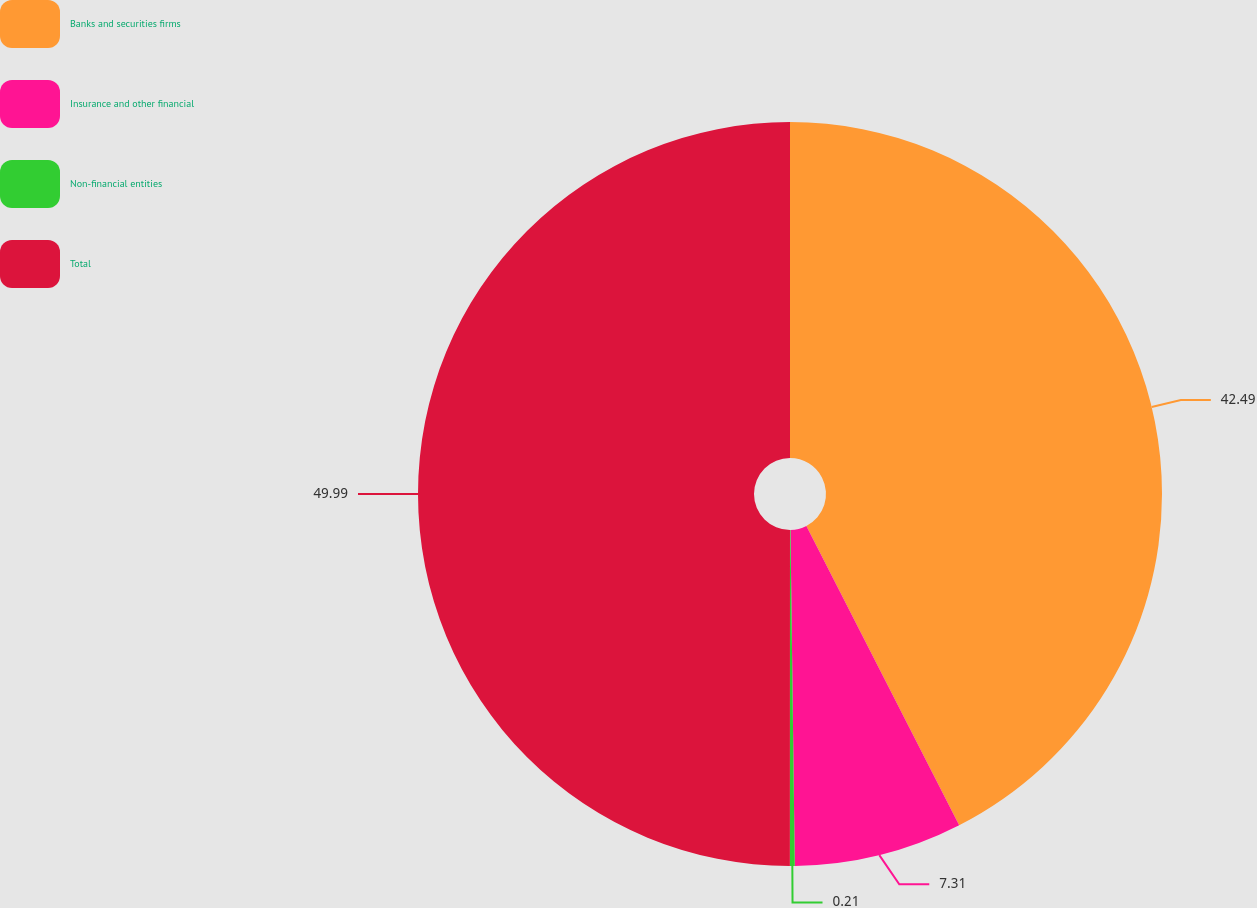<chart> <loc_0><loc_0><loc_500><loc_500><pie_chart><fcel>Banks and securities firms<fcel>Insurance and other financial<fcel>Non-financial entities<fcel>Total<nl><fcel>42.49%<fcel>7.31%<fcel>0.21%<fcel>50.0%<nl></chart> 